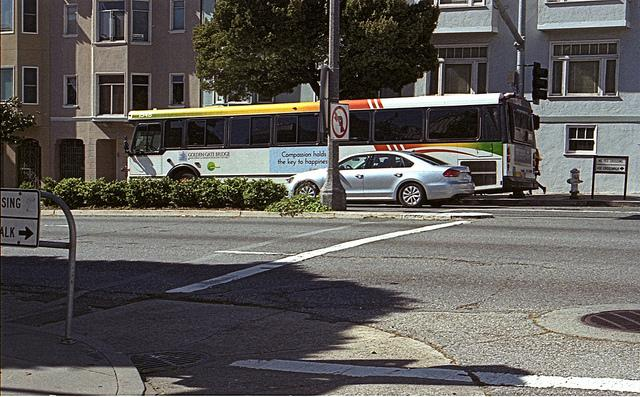What is the car next to? Please explain your reasoning. bus. It is a large vehicle for moving many people at a time. 